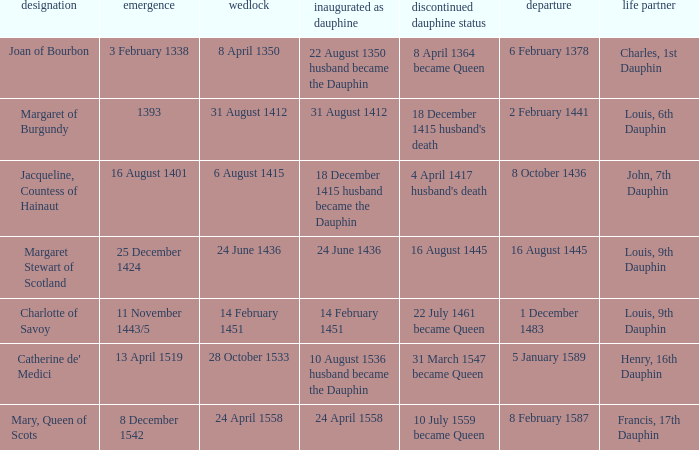When was the death of the person with husband charles, 1st dauphin? 6 February 1378. 